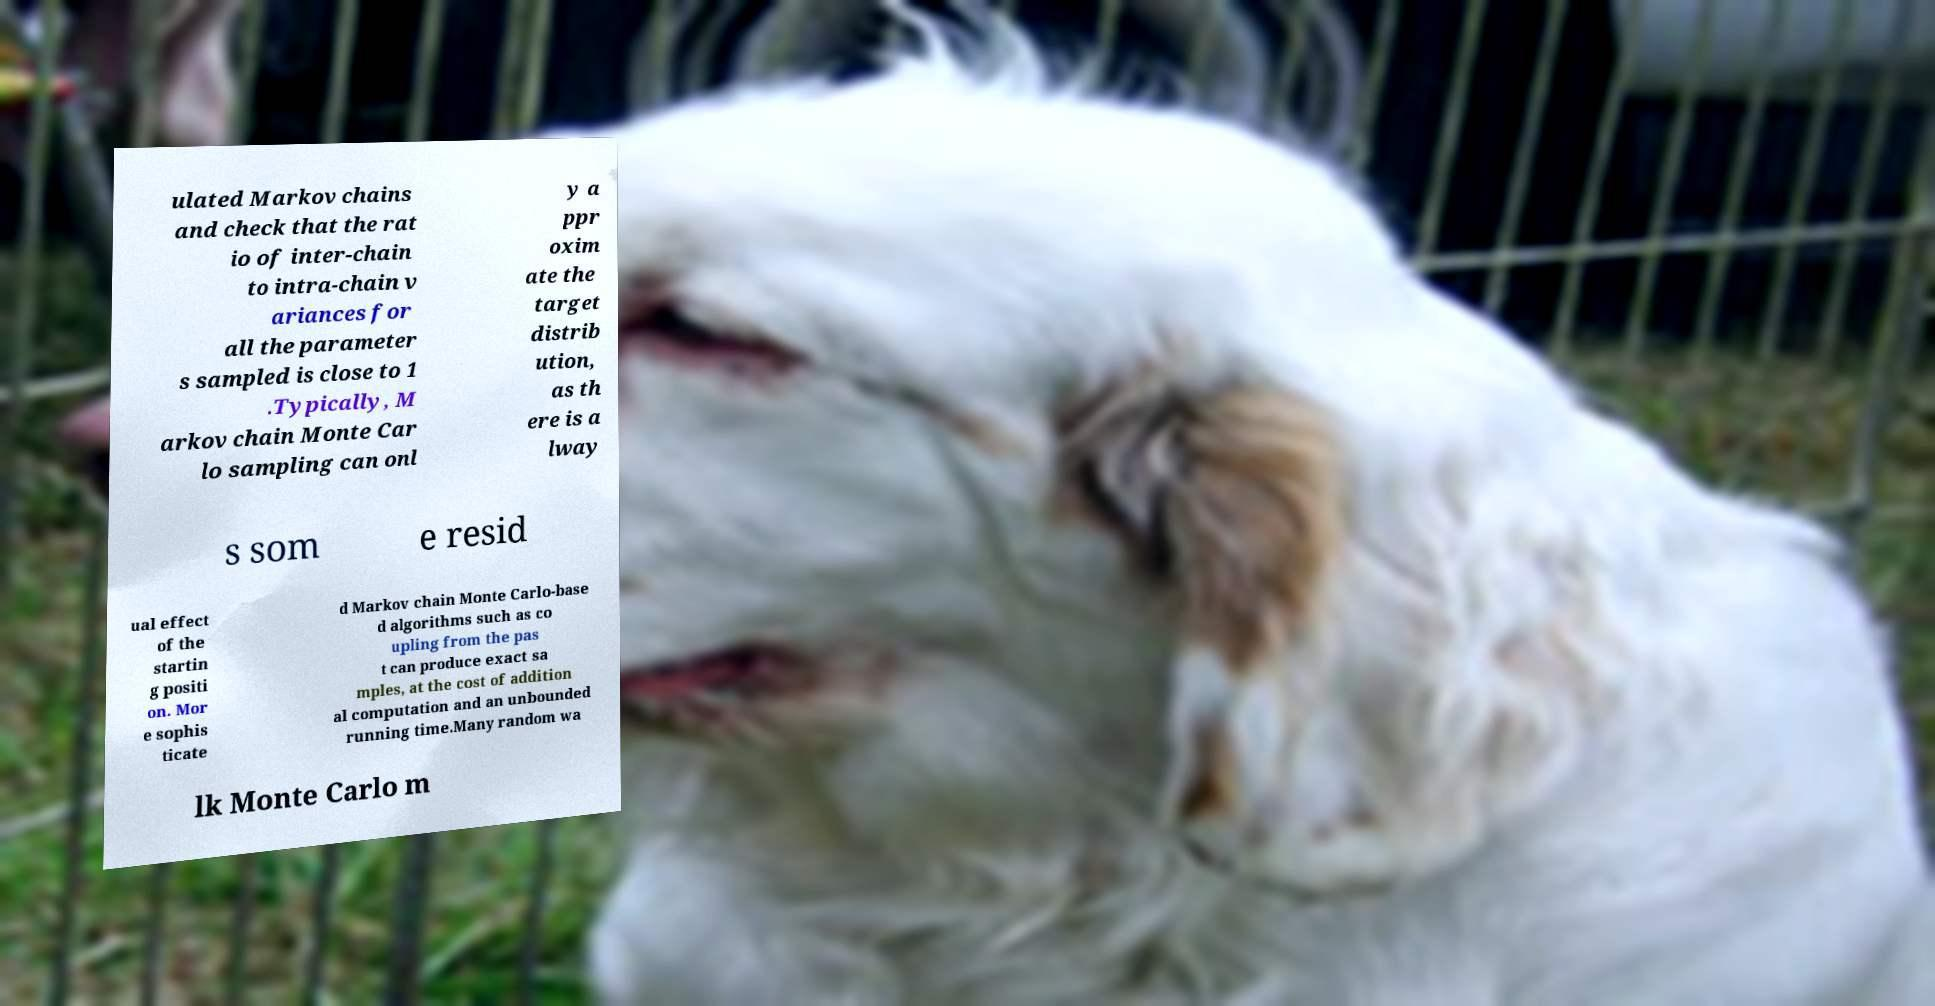Could you assist in decoding the text presented in this image and type it out clearly? ulated Markov chains and check that the rat io of inter-chain to intra-chain v ariances for all the parameter s sampled is close to 1 .Typically, M arkov chain Monte Car lo sampling can onl y a ppr oxim ate the target distrib ution, as th ere is a lway s som e resid ual effect of the startin g positi on. Mor e sophis ticate d Markov chain Monte Carlo-base d algorithms such as co upling from the pas t can produce exact sa mples, at the cost of addition al computation and an unbounded running time.Many random wa lk Monte Carlo m 